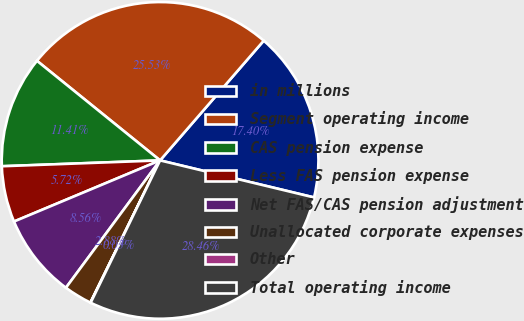Convert chart to OTSL. <chart><loc_0><loc_0><loc_500><loc_500><pie_chart><fcel>in millions<fcel>Segment operating income<fcel>CAS pension expense<fcel>Less FAS pension expense<fcel>Net FAS/CAS pension adjustment<fcel>Unallocated corporate expenses<fcel>Other<fcel>Total operating income<nl><fcel>17.4%<fcel>25.53%<fcel>11.41%<fcel>5.72%<fcel>8.56%<fcel>2.88%<fcel>0.03%<fcel>28.46%<nl></chart> 